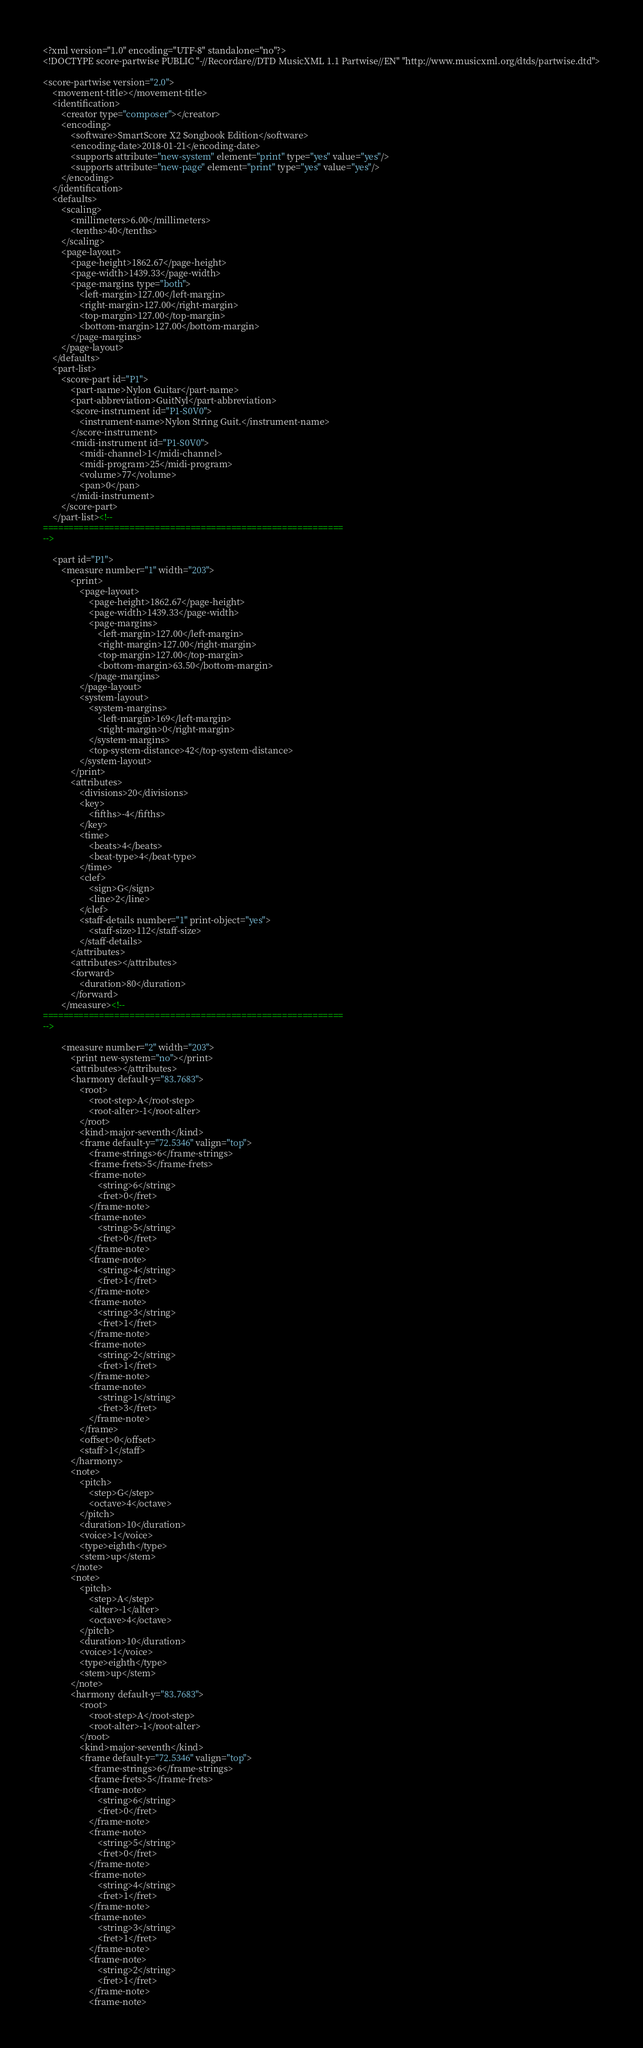Convert code to text. <code><loc_0><loc_0><loc_500><loc_500><_XML_><?xml version="1.0" encoding="UTF-8" standalone="no"?>
<!DOCTYPE score-partwise PUBLIC "-//Recordare//DTD MusicXML 1.1 Partwise//EN" "http://www.musicxml.org/dtds/partwise.dtd">

<score-partwise version="2.0">
	<movement-title></movement-title>
	<identification>
		<creator type="composer"></creator>
		<encoding>
			<software>SmartScore X2 Songbook Edition</software>
			<encoding-date>2018-01-21</encoding-date>
			<supports attribute="new-system" element="print" type="yes" value="yes"/>
			<supports attribute="new-page" element="print" type="yes" value="yes"/>
		</encoding>
	</identification>
	<defaults>
		<scaling>
			<millimeters>6.00</millimeters>
			<tenths>40</tenths>
		</scaling>
		<page-layout>
			<page-height>1862.67</page-height>
			<page-width>1439.33</page-width>
			<page-margins type="both">
				<left-margin>127.00</left-margin>
				<right-margin>127.00</right-margin>
				<top-margin>127.00</top-margin>
				<bottom-margin>127.00</bottom-margin>
			</page-margins>
		</page-layout>
	</defaults>
	<part-list>
		<score-part id="P1">
			<part-name>Nylon Guitar</part-name>
			<part-abbreviation>GuitNyl</part-abbreviation>
			<score-instrument id="P1-S0V0">
				<instrument-name>Nylon String Guit.</instrument-name>
			</score-instrument>
			<midi-instrument id="P1-S0V0">
				<midi-channel>1</midi-channel>
				<midi-program>25</midi-program>
				<volume>77</volume>
				<pan>0</pan>
			</midi-instrument>
		</score-part>
	</part-list><!--
===========================================================
-->

	<part id="P1">
		<measure number="1" width="203">
			<print>
				<page-layout>
					<page-height>1862.67</page-height>
					<page-width>1439.33</page-width>
					<page-margins>
						<left-margin>127.00</left-margin>
						<right-margin>127.00</right-margin>
						<top-margin>127.00</top-margin>
						<bottom-margin>63.50</bottom-margin>
					</page-margins>
				</page-layout>
				<system-layout>
					<system-margins>
						<left-margin>169</left-margin>
						<right-margin>0</right-margin>
					</system-margins>
					<top-system-distance>42</top-system-distance>
				</system-layout>
			</print>
			<attributes>
				<divisions>20</divisions>
				<key>
					<fifths>-4</fifths>
				</key>
				<time>
					<beats>4</beats>
					<beat-type>4</beat-type>
				</time>
				<clef>
					<sign>G</sign>
					<line>2</line>
				</clef>
				<staff-details number="1" print-object="yes">
					<staff-size>112</staff-size>
				</staff-details>
			</attributes>
			<attributes></attributes>
			<forward>
				<duration>80</duration>
			</forward>
		</measure><!--
===========================================================
-->

		<measure number="2" width="203">
			<print new-system="no"></print>
			<attributes></attributes>
			<harmony default-y="83.7683">
				<root>
					<root-step>A</root-step>
					<root-alter>-1</root-alter>
				</root>
				<kind>major-seventh</kind>
				<frame default-y="72.5346" valign="top">
					<frame-strings>6</frame-strings>
					<frame-frets>5</frame-frets>
					<frame-note>
						<string>6</string>
						<fret>0</fret>
					</frame-note>
					<frame-note>
						<string>5</string>
						<fret>0</fret>
					</frame-note>
					<frame-note>
						<string>4</string>
						<fret>1</fret>
					</frame-note>
					<frame-note>
						<string>3</string>
						<fret>1</fret>
					</frame-note>
					<frame-note>
						<string>2</string>
						<fret>1</fret>
					</frame-note>
					<frame-note>
						<string>1</string>
						<fret>3</fret>
					</frame-note>
				</frame>
				<offset>0</offset>
				<staff>1</staff>
			</harmony>
			<note>
				<pitch>
					<step>G</step>
					<octave>4</octave>
				</pitch>
				<duration>10</duration>
				<voice>1</voice>
				<type>eighth</type>
				<stem>up</stem>
			</note>
			<note>
				<pitch>
					<step>A</step>
					<alter>-1</alter>
					<octave>4</octave>
				</pitch>
				<duration>10</duration>
				<voice>1</voice>
				<type>eighth</type>
				<stem>up</stem>
			</note>
			<harmony default-y="83.7683">
				<root>
					<root-step>A</root-step>
					<root-alter>-1</root-alter>
				</root>
				<kind>major-seventh</kind>
				<frame default-y="72.5346" valign="top">
					<frame-strings>6</frame-strings>
					<frame-frets>5</frame-frets>
					<frame-note>
						<string>6</string>
						<fret>0</fret>
					</frame-note>
					<frame-note>
						<string>5</string>
						<fret>0</fret>
					</frame-note>
					<frame-note>
						<string>4</string>
						<fret>1</fret>
					</frame-note>
					<frame-note>
						<string>3</string>
						<fret>1</fret>
					</frame-note>
					<frame-note>
						<string>2</string>
						<fret>1</fret>
					</frame-note>
					<frame-note></code> 